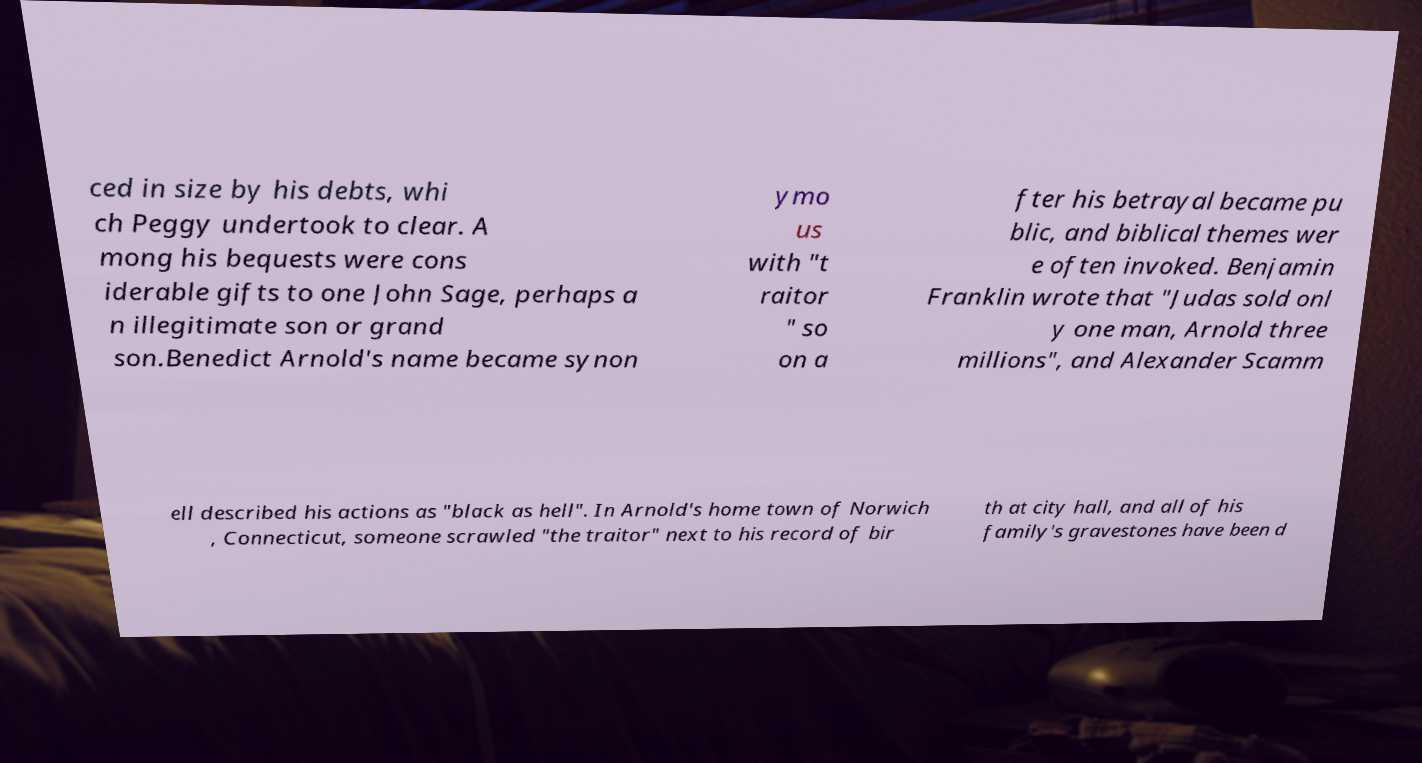There's text embedded in this image that I need extracted. Can you transcribe it verbatim? ced in size by his debts, whi ch Peggy undertook to clear. A mong his bequests were cons iderable gifts to one John Sage, perhaps a n illegitimate son or grand son.Benedict Arnold's name became synon ymo us with "t raitor " so on a fter his betrayal became pu blic, and biblical themes wer e often invoked. Benjamin Franklin wrote that "Judas sold onl y one man, Arnold three millions", and Alexander Scamm ell described his actions as "black as hell". In Arnold's home town of Norwich , Connecticut, someone scrawled "the traitor" next to his record of bir th at city hall, and all of his family's gravestones have been d 